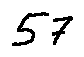Convert formula to latex. <formula><loc_0><loc_0><loc_500><loc_500>5 7</formula> 